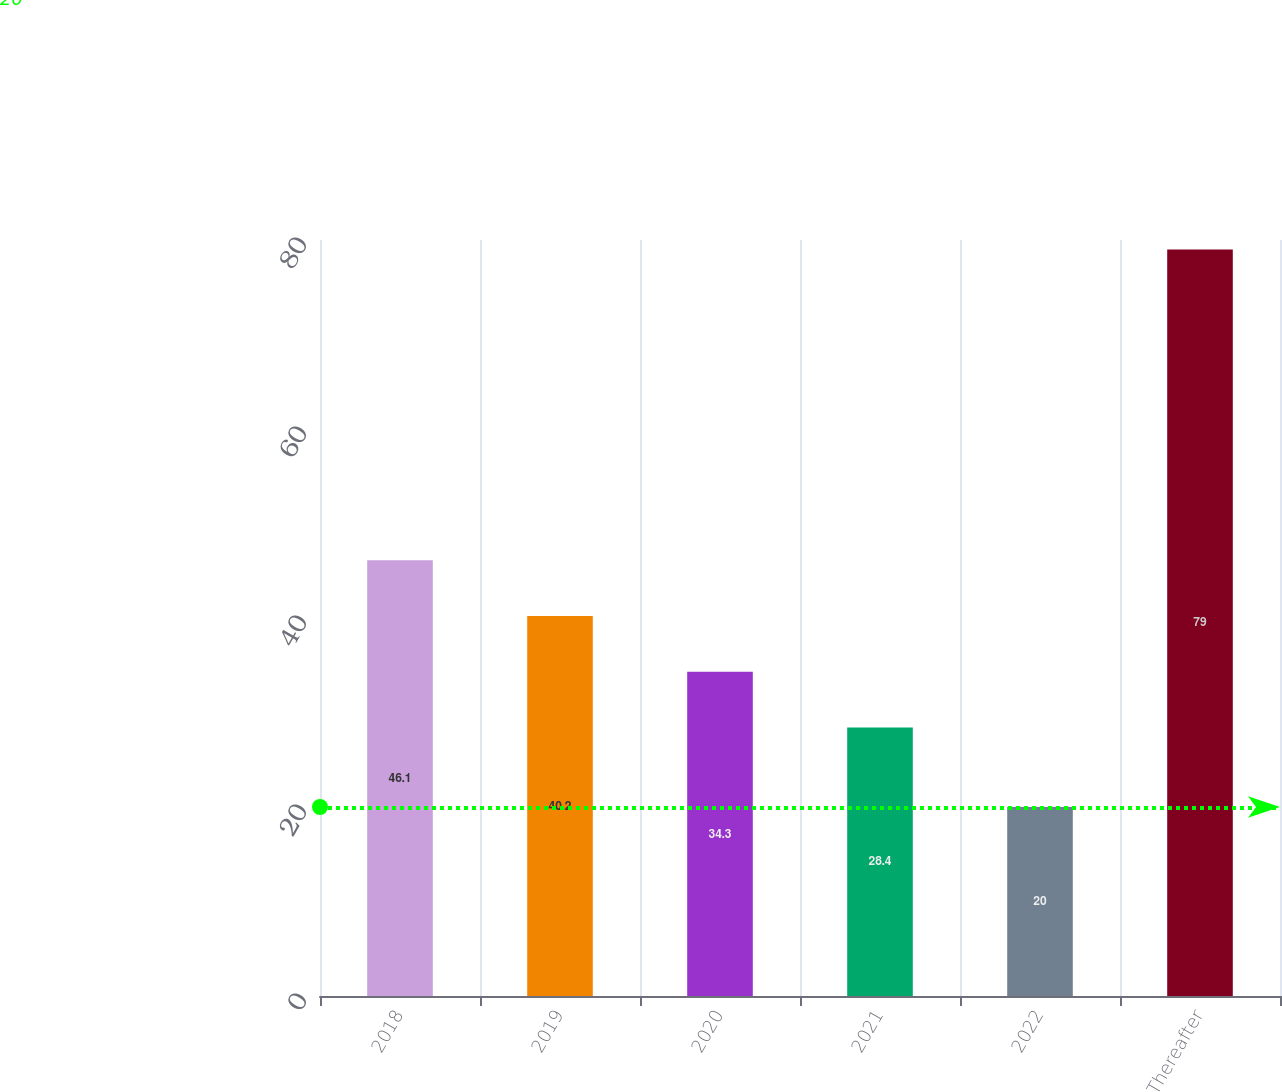<chart> <loc_0><loc_0><loc_500><loc_500><bar_chart><fcel>2018<fcel>2019<fcel>2020<fcel>2021<fcel>2022<fcel>Thereafter<nl><fcel>46.1<fcel>40.2<fcel>34.3<fcel>28.4<fcel>20<fcel>79<nl></chart> 